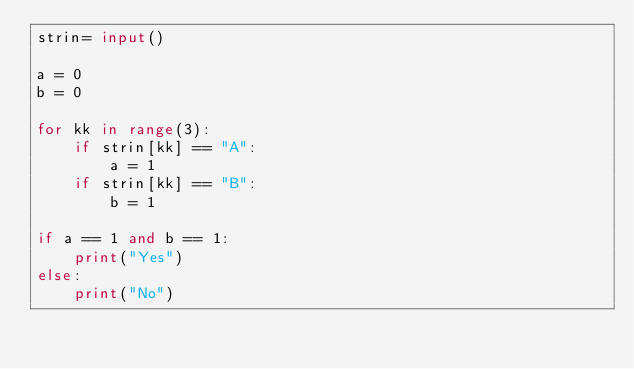<code> <loc_0><loc_0><loc_500><loc_500><_Python_>strin= input()

a = 0
b = 0

for kk in range(3):
    if strin[kk] == "A":
        a = 1
    if strin[kk] == "B":
        b = 1

if a == 1 and b == 1:
    print("Yes")
else:
    print("No")</code> 